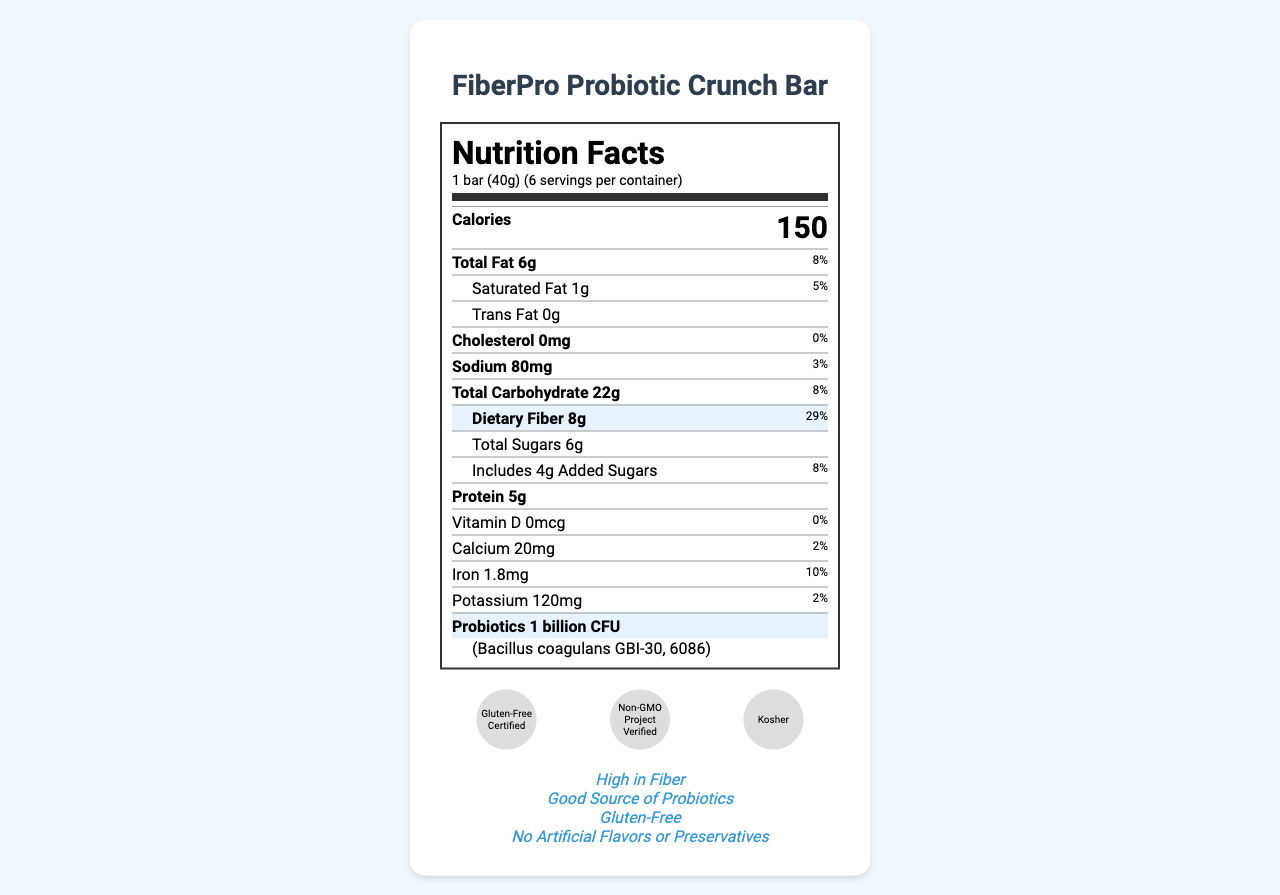what is the serving size for the FiberPro Probiotic Crunch Bar? The serving size is mentioned as "1 bar (40g)" in the document.
Answer: 1 bar (40g) how many servings are there per container? The document states there are 6 servings per container.
Answer: 6 how many calories are in one serving of the snack bar? The document lists the calories per serving as 150.
Answer: 150 what is the amount of dietary fiber per serving? The document specifies that each serving contains 8g of dietary fiber.
Answer: 8g what is the daily value percentage for dietary fiber? The daily value for dietary fiber is given as 29% in the document.
Answer: 29% which probiotic strain is used in the FiberPro Probiotic Crunch Bar? A. Lactobacillus acidophilus B. Bacillus coagulans GBI-30, 6086 C. Bifidobacterium longum The document mentions the probiotic strain as Bacillus coagulans GBI-30, 6086.
Answer: B how much sodium does one serving of the snack bar contain? The amount of sodium per serving is listed as 80mg.
Answer: 80mg is the snack bar gluten-free? A. Yes B. No C. Not specified The document indicates that the bar is gluten-free, as well as displaying a "Gluten-Free Certified" certification.
Answer: A does the snack bar contain added sugars? The document shows that there are 4g of added sugars in the snack bar.
Answer: Yes what is the total carbohydrate content per serving? The total carbohydrate content per serving is stated to be 22g.
Answer: 22g is there any vitamin D in the snack bar? The document states that there is 0mcg of vitamin D and 0% of the daily value.
Answer: No does the ingredient list include any artificial flavors or preservatives? The marketing claims include "No Artificial Flavors or Preservatives," indicating that the ingredient list does not contain these.
Answer: No can you summarize the main points of the document? The document is focused on presenting the nutrition and health benefits of the FiberPro Probiotic Crunch Bar. It details serving size, caloric content, macronutrients, vitamins, minerals, and specific claims related to fiber and probiotics. Certifications and allergen information are also included.
Answer: The document provides detailed nutrition facts for the FiberPro Probiotic Crunch Bar, highlighting its high fiber and probiotic content. Key features include 8g of dietary fiber, 1 billion CFU of Bacillus coagulans probiotics, and certification as gluten-free. It also emphasizes the absence of artificial flavors or preservatives. what is the last updated date for this nutrition information? The last updated date is provided as May 15, 2023, in the document.
Answer: May 15, 2023 is there any information on calcium content? The document states the calcium content is 20mg per serving, with a daily value of 2%.
Answer: Yes who is the manufacturer of the FiberPro Probiotic Crunch Bar? The document names HealthySnacks Inc. as the manufacturer.
Answer: HealthySnacks Inc. what is the customer service contact number? The customer service contact number provided in the document is +1 (800) 555-1234.
Answer: +1 (800) 555-1234 what was the development process for the nutritional data? The document does not provide any information regarding the development process for the nutritional data.
Answer: Not enough information 